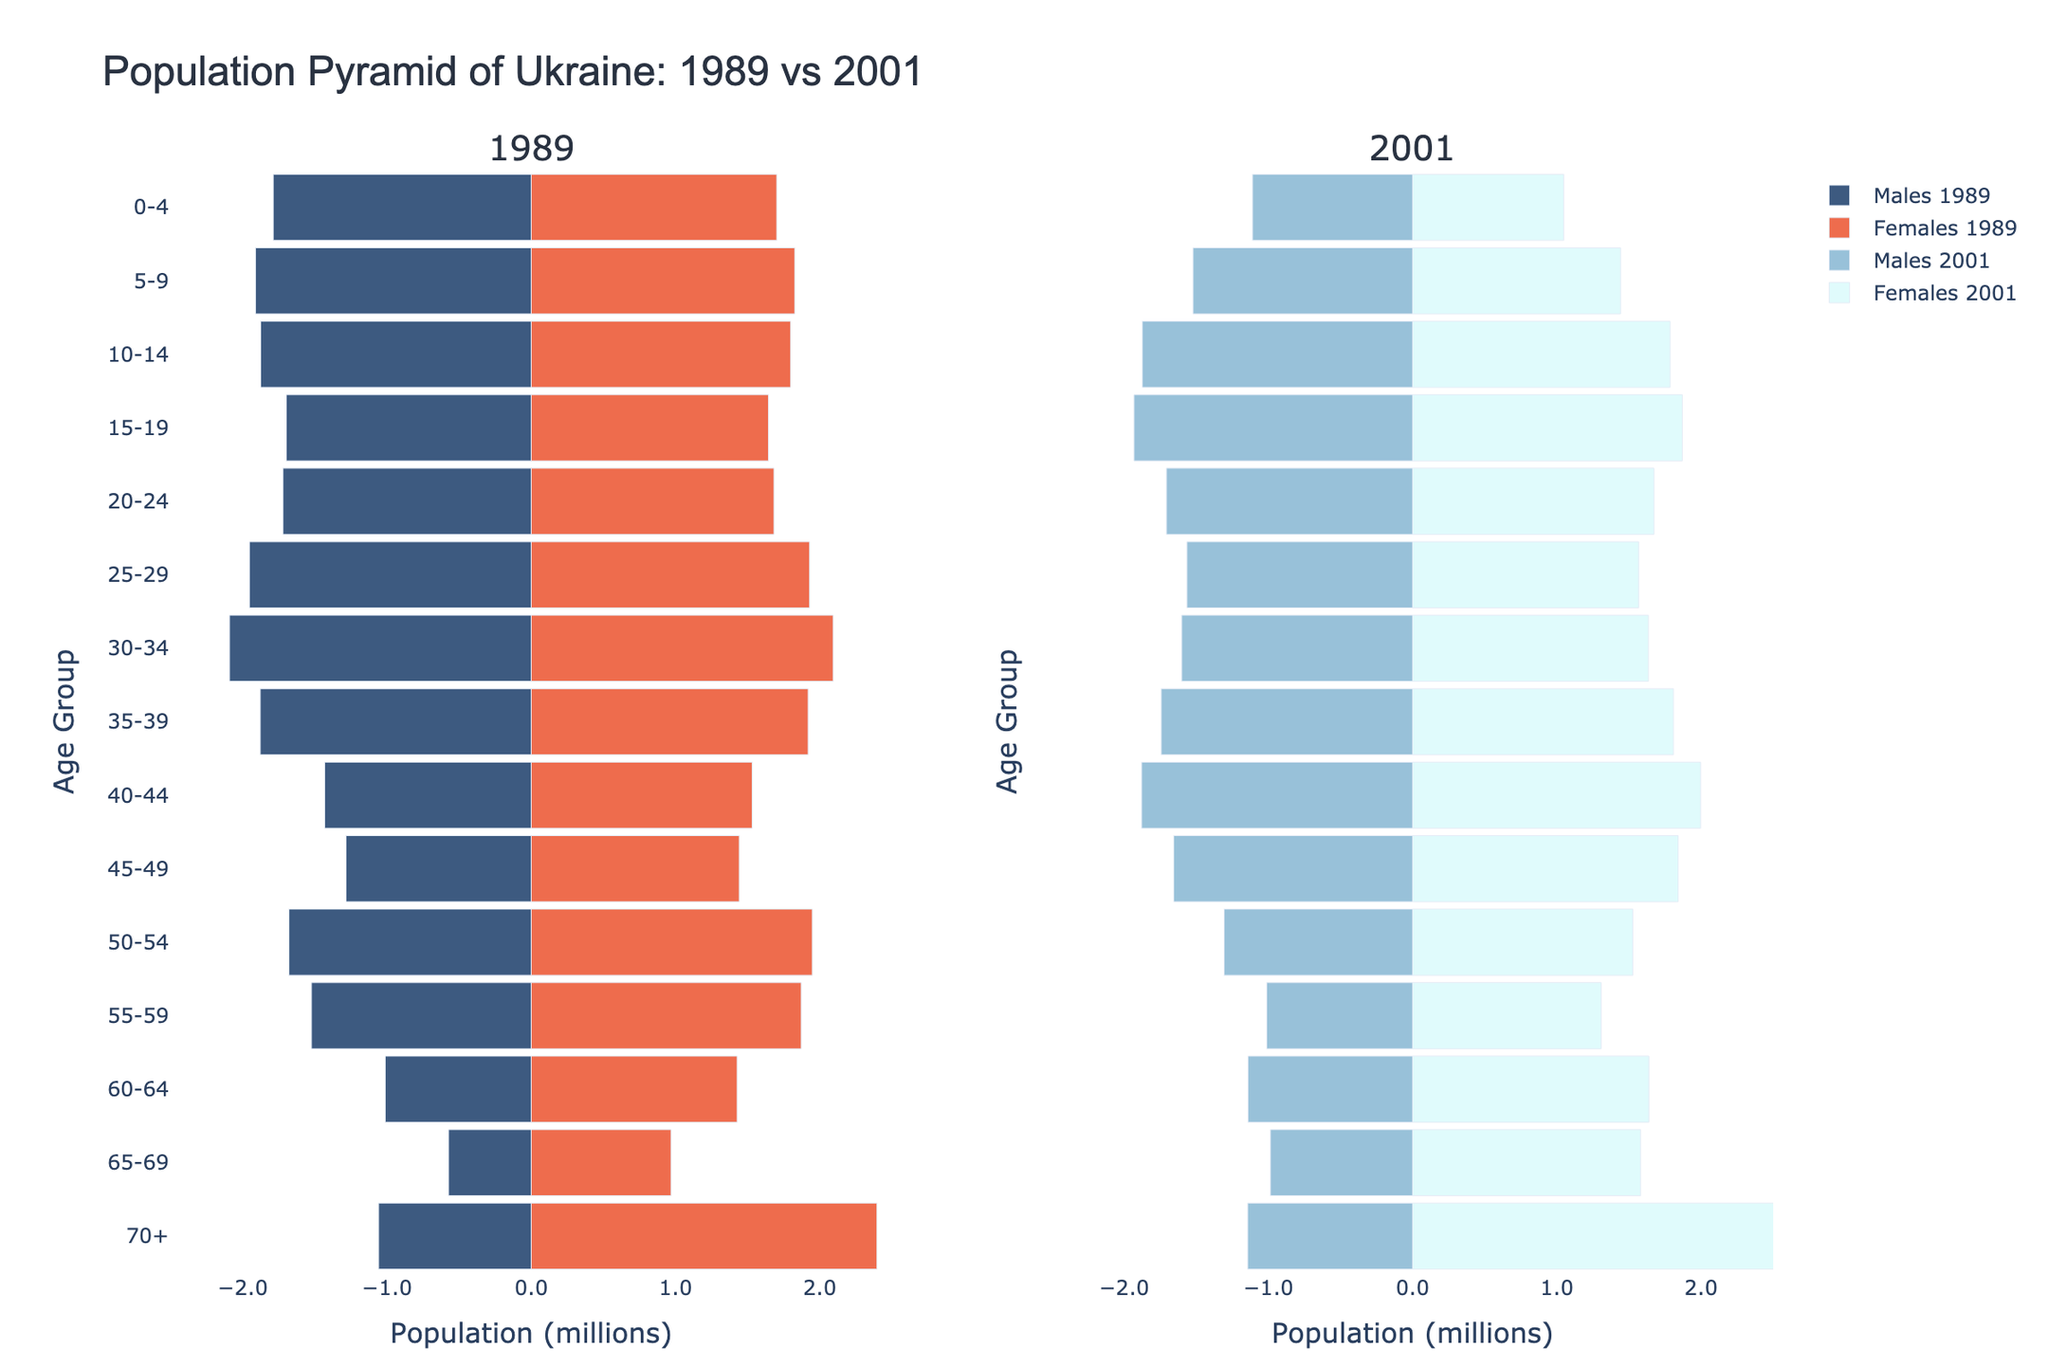What is the title of the figure? The title is located at the top of the figure and reads "Population Pyramid of Ukraine: 1989 vs 2001".
Answer: Population Pyramid of Ukraine: 1989 vs 2001 Which year has a higher population of males aged 0-4? Compare the male population aged 0-4 in 1989 and 2001. In 1989, it is 1,789,000, while in 2001, it is 1,110,000. Thus, 1989 has a higher population of males aged 0-4.
Answer: 1989 How does the female population aged 70+ in 1989 compare to that in 2001? Look at the bars for females aged 70+ in both years. In 1989, the population is 2,397,000, compared to 2,640,000 in 2001. Thus, the female population aged 70+ is higher in 2001.
Answer: 2001 Which age group saw the largest decrease in the male population from 1989 to 2001? Compare the male populations across the age groups from 1989 to 2001. The age group 0-4 saw a decrease from 1,789,000 to 1,110,000, which is the largest decrease.
Answer: 0-4 For the age group 45-49, how did the population change for both males and females from 1989 to 2001? Compare the 1989 and 2001 populations for both genders in this age group. Males increased from 1,284,000 to 1,657,000, and females increased from 1,442,000 to 1,841,000.
Answer: Both males and females increased What proportion of the 15-19 age group was male in 2001? Add the populations of males and females in the 15-19 age group for 2001: 1,932,000 (males) + 1,870,000 (females) = 3,802,000. The male proportion is then 1,932,000 / 3,802,000.
Answer: Approximately 50.8% Compare the total population for the age group 20-24 in 1989 and 2001. Add the male and female populations for the 20-24 age group in both years. For 1989: 1,721,000 (males) + 1,683,000 (females) = 3,404,000. For 2001: 1,707,000 (males) + 1,673,000 (females) = 3,380,000.
Answer: Higher in 1989 Which year had more balance in the population distribution among genders for the age group 35-39? Look at the bars for both genders in the 35-39 age group. In 1989, males: 1,879,000, females: 1,920,000. In 2001, males: 1,743,000, females: 1,808,000. The difference between genders is smaller in 2001 (65,000) compared to 1989 (41,000).
Answer: 2001 What trend can be observed in the older age groups (65+ and 70+) from 1989 to 2001? Compare the figures for both genders in the older age groups. Both the male and female populations increase significantly, indicating an aging population.
Answer: Aging population Which age group had a higher female population than male in both years (1989 and 2001)? Check each age group and identify where females consistently outnumber males. The age groups 55-59, 60-64, 65-69, and 70+ consistently have higher female populations in both years.
Answer: 55-59, 60-64, 65-69, and 70+ 